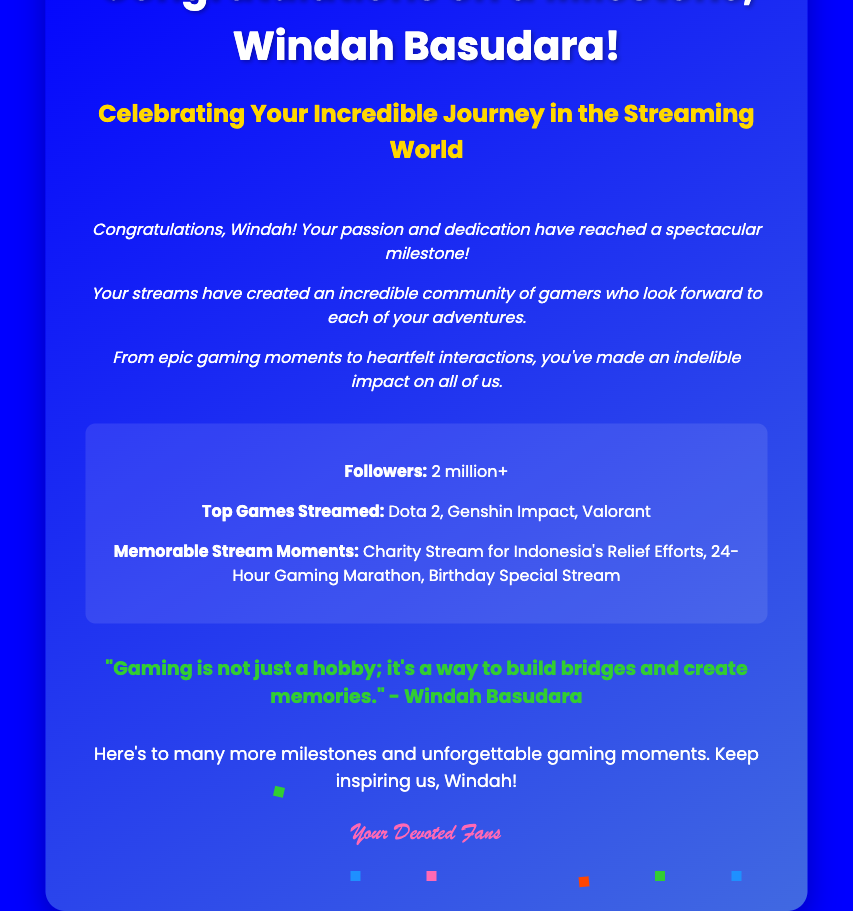What is the title of the card? The title appears prominently at the top of the card.
Answer: Congratulations on a Milestone, Windah Basudara! How many followers does Windah Basudara have? The card includes a statistic about Windah's followers.
Answer: 2 million+ What color is the card's background? The background color is specified in the document's style.
Answer: Blue What is one of the top games streamed by Windah? The card lists some of Windah's top streamed games.
Answer: Dota 2 What is the main theme of the card? The card celebrates a specific achievement in Windah's career.
Answer: Milestone Celebration What kind of community has Windah built? The document mentions the type of community Windah’s streams have created.
Answer: Incredible community of gamers What animated feature is included in the card? The document describes a decorative element used in the card.
Answer: Confetti What quote is featured in the card? The card includes a motivational quote attributed to Windah.
Answer: "Gaming is not just a hobby; it's a way to build bridges and create memories." Who are the intended recipients of the card's sign-off? The sign-off is directed towards a specific audience.
Answer: Devoted Fans 